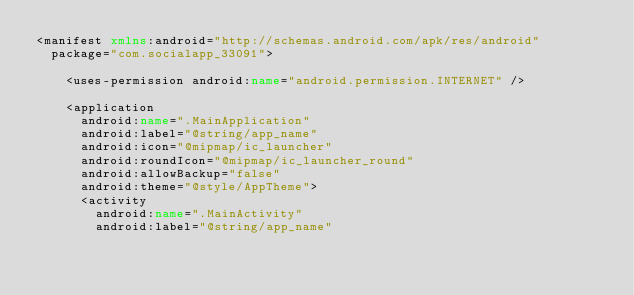Convert code to text. <code><loc_0><loc_0><loc_500><loc_500><_XML_><manifest xmlns:android="http://schemas.android.com/apk/res/android"
  package="com.socialapp_33091">

    <uses-permission android:name="android.permission.INTERNET" />

    <application
      android:name=".MainApplication"
      android:label="@string/app_name"
      android:icon="@mipmap/ic_launcher"
      android:roundIcon="@mipmap/ic_launcher_round"
      android:allowBackup="false"
      android:theme="@style/AppTheme">
      <activity
        android:name=".MainActivity"
        android:label="@string/app_name"</code> 